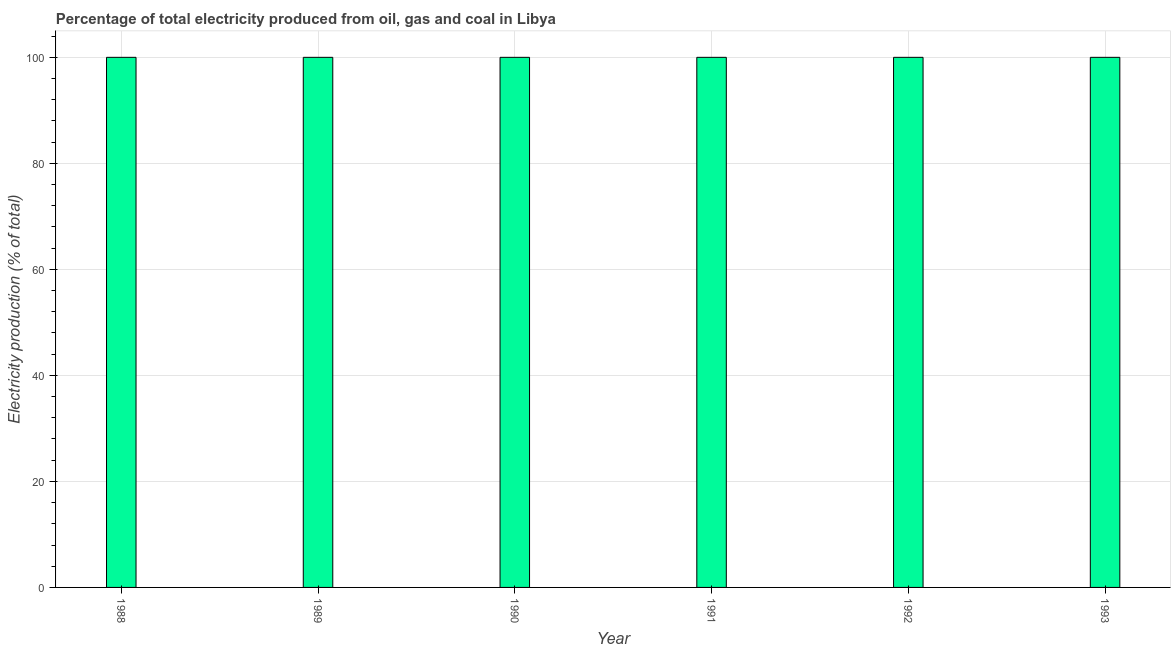Does the graph contain any zero values?
Keep it short and to the point. No. What is the title of the graph?
Offer a terse response. Percentage of total electricity produced from oil, gas and coal in Libya. What is the label or title of the X-axis?
Offer a terse response. Year. What is the label or title of the Y-axis?
Ensure brevity in your answer.  Electricity production (% of total). Across all years, what is the maximum electricity production?
Keep it short and to the point. 100. In which year was the electricity production maximum?
Offer a terse response. 1988. In which year was the electricity production minimum?
Offer a very short reply. 1988. What is the sum of the electricity production?
Offer a very short reply. 600. In how many years, is the electricity production greater than 76 %?
Offer a terse response. 6. Do a majority of the years between 1991 and 1990 (inclusive) have electricity production greater than 68 %?
Your answer should be compact. No. What is the ratio of the electricity production in 1988 to that in 1991?
Your response must be concise. 1. Is the difference between the electricity production in 1988 and 1989 greater than the difference between any two years?
Give a very brief answer. Yes. What is the difference between the highest and the second highest electricity production?
Ensure brevity in your answer.  0. How many bars are there?
Your response must be concise. 6. How many years are there in the graph?
Your answer should be compact. 6. What is the difference between two consecutive major ticks on the Y-axis?
Give a very brief answer. 20. Are the values on the major ticks of Y-axis written in scientific E-notation?
Keep it short and to the point. No. What is the Electricity production (% of total) in 1993?
Make the answer very short. 100. What is the difference between the Electricity production (% of total) in 1988 and 1989?
Offer a very short reply. 0. What is the difference between the Electricity production (% of total) in 1988 and 1990?
Keep it short and to the point. 0. What is the difference between the Electricity production (% of total) in 1988 and 1991?
Keep it short and to the point. 0. What is the difference between the Electricity production (% of total) in 1988 and 1993?
Ensure brevity in your answer.  0. What is the difference between the Electricity production (% of total) in 1989 and 1992?
Your answer should be compact. 0. What is the difference between the Electricity production (% of total) in 1989 and 1993?
Your response must be concise. 0. What is the difference between the Electricity production (% of total) in 1990 and 1991?
Give a very brief answer. 0. What is the difference between the Electricity production (% of total) in 1990 and 1992?
Your answer should be very brief. 0. What is the difference between the Electricity production (% of total) in 1991 and 1992?
Your answer should be very brief. 0. What is the ratio of the Electricity production (% of total) in 1988 to that in 1990?
Keep it short and to the point. 1. What is the ratio of the Electricity production (% of total) in 1988 to that in 1991?
Your answer should be very brief. 1. What is the ratio of the Electricity production (% of total) in 1989 to that in 1990?
Your answer should be very brief. 1. What is the ratio of the Electricity production (% of total) in 1989 to that in 1991?
Give a very brief answer. 1. What is the ratio of the Electricity production (% of total) in 1989 to that in 1992?
Offer a very short reply. 1. What is the ratio of the Electricity production (% of total) in 1990 to that in 1991?
Provide a succinct answer. 1. What is the ratio of the Electricity production (% of total) in 1991 to that in 1992?
Ensure brevity in your answer.  1. 